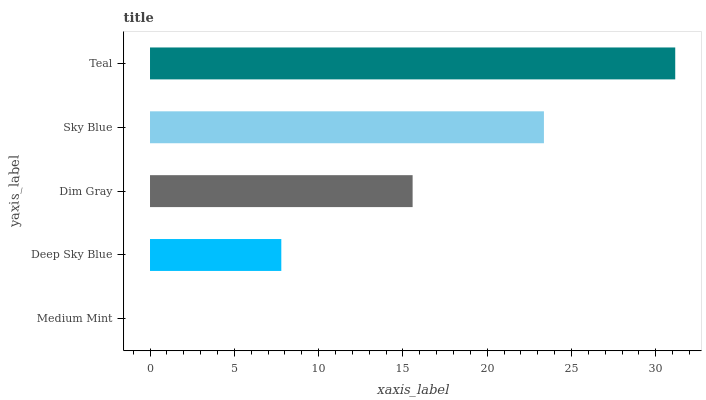Is Medium Mint the minimum?
Answer yes or no. Yes. Is Teal the maximum?
Answer yes or no. Yes. Is Deep Sky Blue the minimum?
Answer yes or no. No. Is Deep Sky Blue the maximum?
Answer yes or no. No. Is Deep Sky Blue greater than Medium Mint?
Answer yes or no. Yes. Is Medium Mint less than Deep Sky Blue?
Answer yes or no. Yes. Is Medium Mint greater than Deep Sky Blue?
Answer yes or no. No. Is Deep Sky Blue less than Medium Mint?
Answer yes or no. No. Is Dim Gray the high median?
Answer yes or no. Yes. Is Dim Gray the low median?
Answer yes or no. Yes. Is Deep Sky Blue the high median?
Answer yes or no. No. Is Sky Blue the low median?
Answer yes or no. No. 